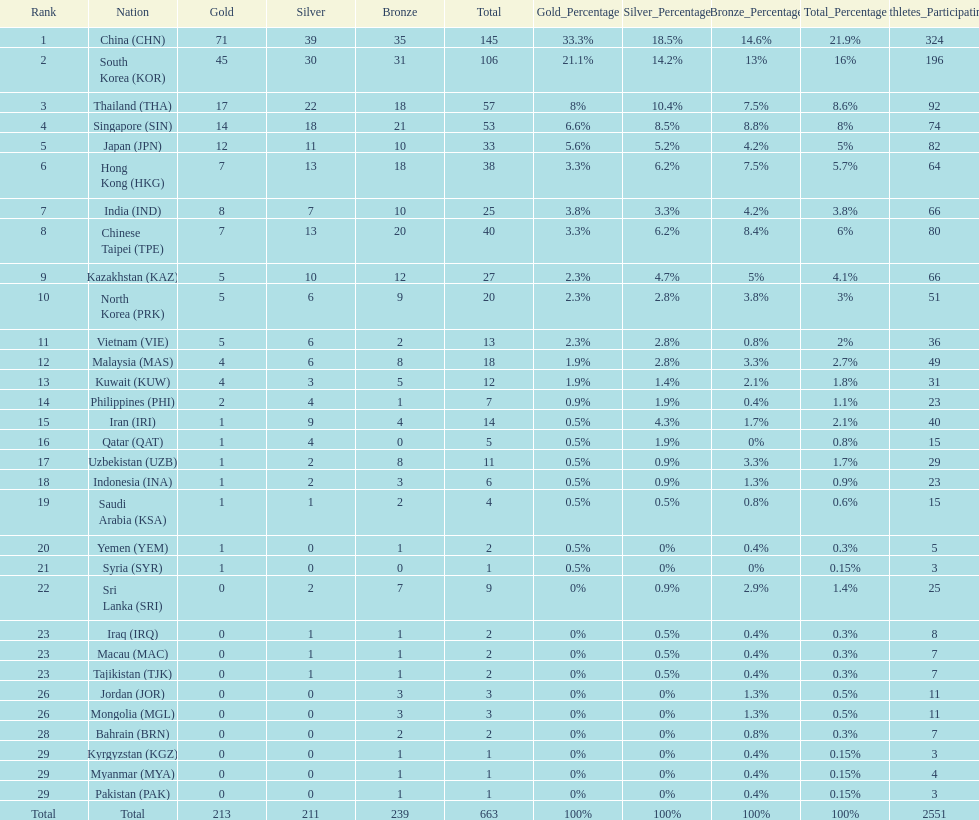What is the difference between the total amount of medals won by qatar and indonesia? 1. 